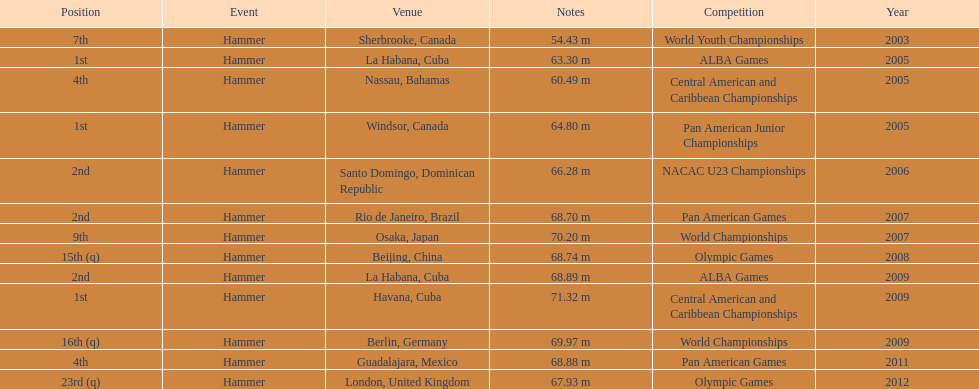In which olympic games did arasay thondike not finish in the top 20? 2012. 